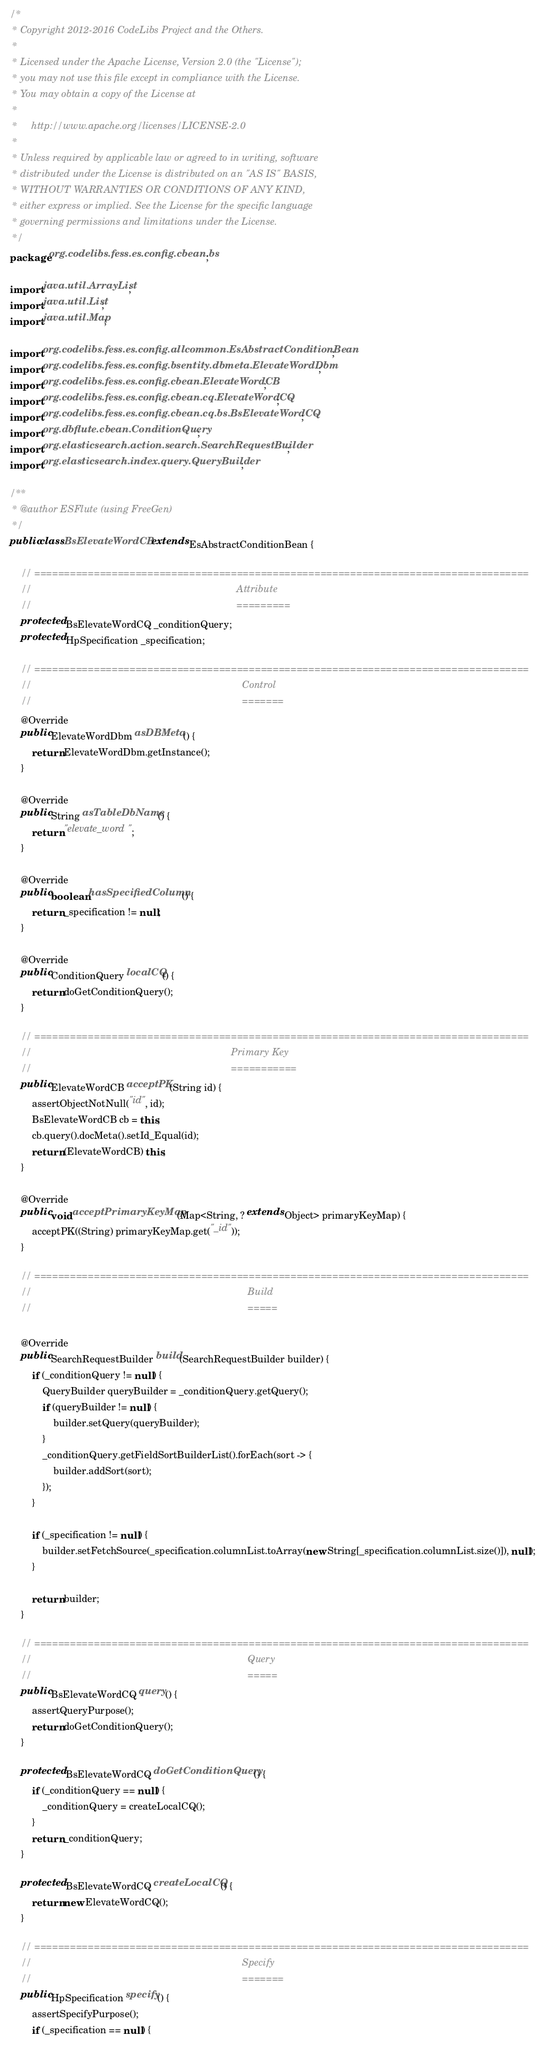Convert code to text. <code><loc_0><loc_0><loc_500><loc_500><_Java_>/*
 * Copyright 2012-2016 CodeLibs Project and the Others.
 *
 * Licensed under the Apache License, Version 2.0 (the "License");
 * you may not use this file except in compliance with the License.
 * You may obtain a copy of the License at
 *
 *     http://www.apache.org/licenses/LICENSE-2.0
 *
 * Unless required by applicable law or agreed to in writing, software
 * distributed under the License is distributed on an "AS IS" BASIS,
 * WITHOUT WARRANTIES OR CONDITIONS OF ANY KIND,
 * either express or implied. See the License for the specific language
 * governing permissions and limitations under the License.
 */
package org.codelibs.fess.es.config.cbean.bs;

import java.util.ArrayList;
import java.util.List;
import java.util.Map;

import org.codelibs.fess.es.config.allcommon.EsAbstractConditionBean;
import org.codelibs.fess.es.config.bsentity.dbmeta.ElevateWordDbm;
import org.codelibs.fess.es.config.cbean.ElevateWordCB;
import org.codelibs.fess.es.config.cbean.cq.ElevateWordCQ;
import org.codelibs.fess.es.config.cbean.cq.bs.BsElevateWordCQ;
import org.dbflute.cbean.ConditionQuery;
import org.elasticsearch.action.search.SearchRequestBuilder;
import org.elasticsearch.index.query.QueryBuilder;

/**
 * @author ESFlute (using FreeGen)
 */
public class BsElevateWordCB extends EsAbstractConditionBean {

    // ===================================================================================
    //                                                                           Attribute
    //                                                                           =========
    protected BsElevateWordCQ _conditionQuery;
    protected HpSpecification _specification;

    // ===================================================================================
    //                                                                             Control
    //                                                                             =======
    @Override
    public ElevateWordDbm asDBMeta() {
        return ElevateWordDbm.getInstance();
    }

    @Override
    public String asTableDbName() {
        return "elevate_word";
    }

    @Override
    public boolean hasSpecifiedColumn() {
        return _specification != null;
    }

    @Override
    public ConditionQuery localCQ() {
        return doGetConditionQuery();
    }

    // ===================================================================================
    //                                                                         Primary Key
    //                                                                         ===========
    public ElevateWordCB acceptPK(String id) {
        assertObjectNotNull("id", id);
        BsElevateWordCB cb = this;
        cb.query().docMeta().setId_Equal(id);
        return (ElevateWordCB) this;
    }

    @Override
    public void acceptPrimaryKeyMap(Map<String, ? extends Object> primaryKeyMap) {
        acceptPK((String) primaryKeyMap.get("_id"));
    }

    // ===================================================================================
    //                                                                               Build
    //                                                                               =====

    @Override
    public SearchRequestBuilder build(SearchRequestBuilder builder) {
        if (_conditionQuery != null) {
            QueryBuilder queryBuilder = _conditionQuery.getQuery();
            if (queryBuilder != null) {
                builder.setQuery(queryBuilder);
            }
            _conditionQuery.getFieldSortBuilderList().forEach(sort -> {
                builder.addSort(sort);
            });
        }

        if (_specification != null) {
            builder.setFetchSource(_specification.columnList.toArray(new String[_specification.columnList.size()]), null);
        }

        return builder;
    }

    // ===================================================================================
    //                                                                               Query
    //                                                                               =====
    public BsElevateWordCQ query() {
        assertQueryPurpose();
        return doGetConditionQuery();
    }

    protected BsElevateWordCQ doGetConditionQuery() {
        if (_conditionQuery == null) {
            _conditionQuery = createLocalCQ();
        }
        return _conditionQuery;
    }

    protected BsElevateWordCQ createLocalCQ() {
        return new ElevateWordCQ();
    }

    // ===================================================================================
    //                                                                             Specify
    //                                                                             =======
    public HpSpecification specify() {
        assertSpecifyPurpose();
        if (_specification == null) {</code> 